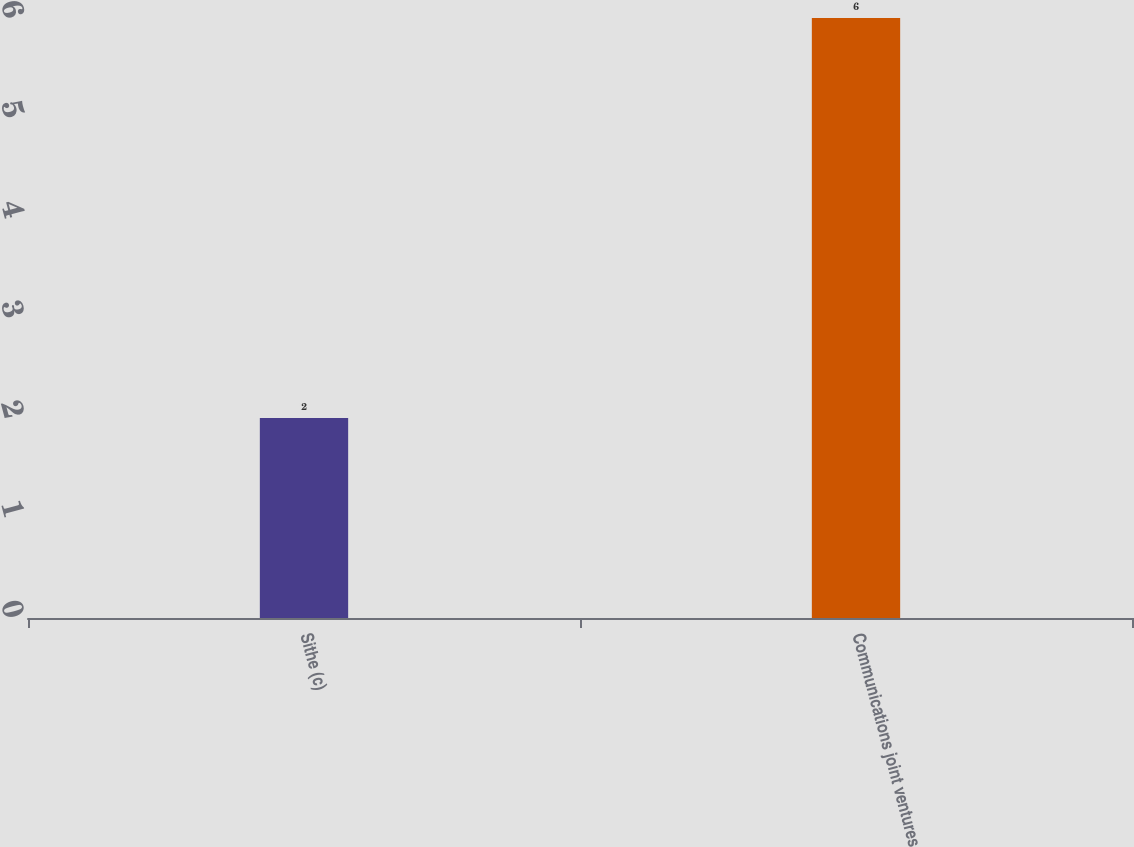Convert chart to OTSL. <chart><loc_0><loc_0><loc_500><loc_500><bar_chart><fcel>Sithe (c)<fcel>Communications joint ventures<nl><fcel>2<fcel>6<nl></chart> 